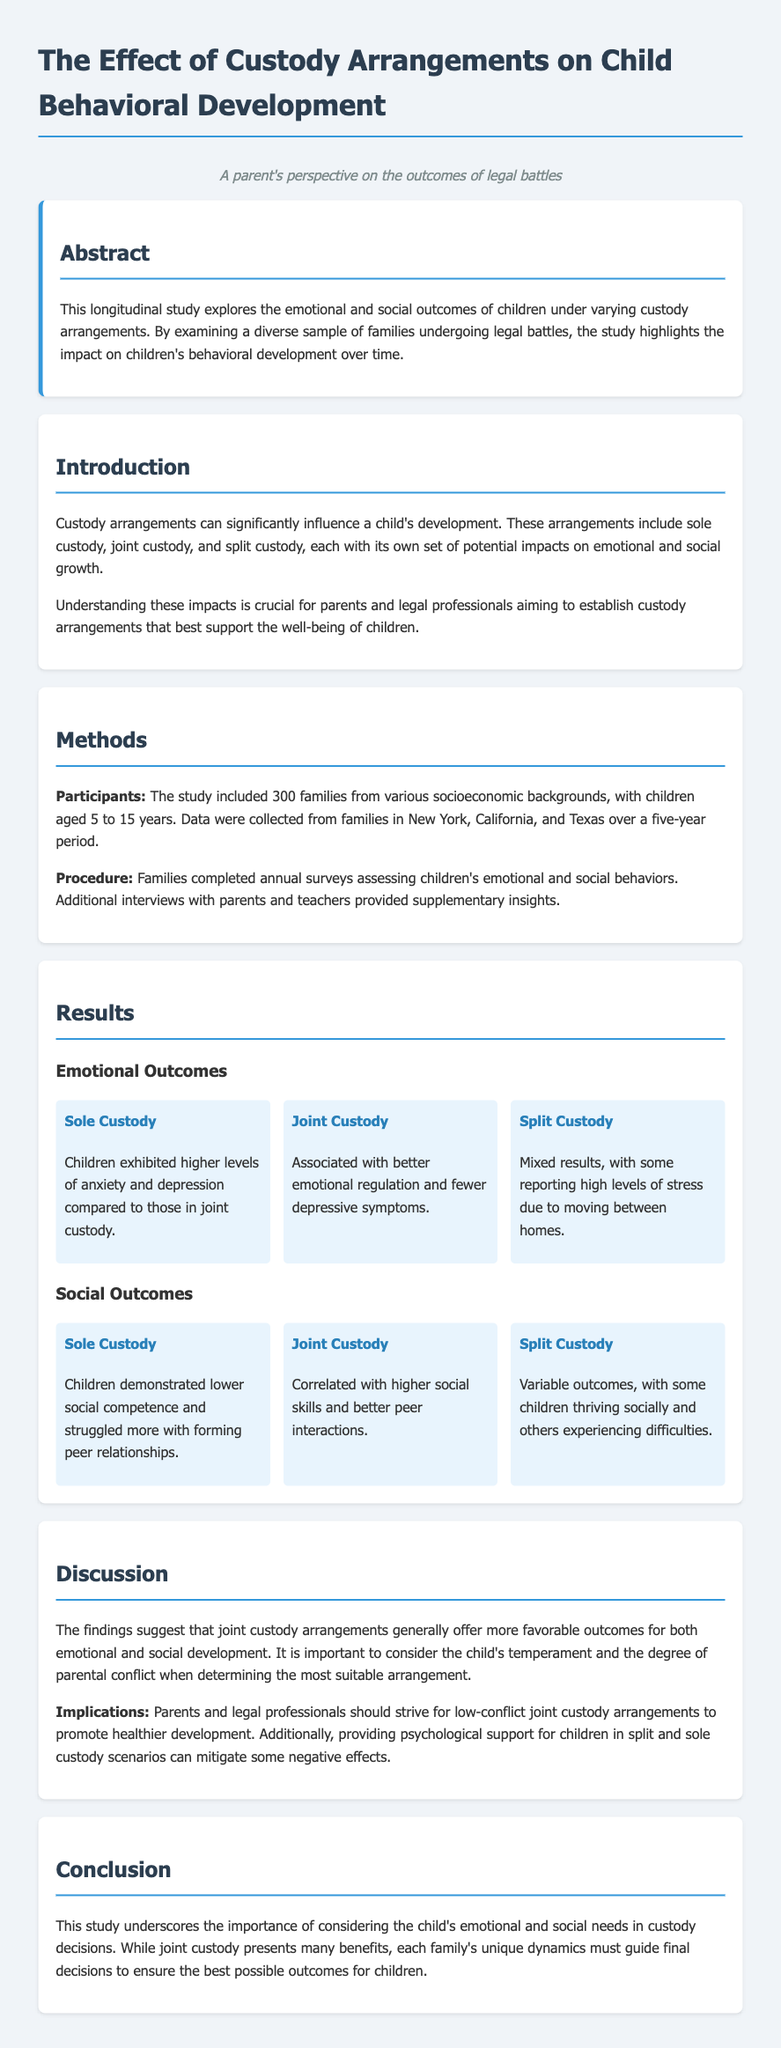what is the focus of the study? The focus of the study is on the emotional and social outcomes of children under varying custody arrangements.
Answer: emotional and social outcomes how many families participated in the study? The study included a total of 300 families from various socioeconomic backgrounds.
Answer: 300 families which custody arrangement showed higher levels of anxiety and depression in children? The document states that children under sole custody exhibited higher levels of anxiety and depression.
Answer: Sole Custody what was associated with better emotional regulation in children? The study found that joint custody was associated with better emotional regulation.
Answer: Joint Custody how long was the duration of the study? The data were collected over a five-year period.
Answer: five years what negative impact did sole custody have on children's social competence? Children under sole custody demonstrated lower social competence and struggled more with forming peer relationships.
Answer: lower social competence which custody arrangement correlated with higher social skills? The document indicates that joint custody correlated with higher social skills.
Answer: Joint Custody what suggestion is made for children in split custody scenarios? The report suggests providing psychological support for children in split custody scenarios to mitigate negative effects.
Answer: psychological support 